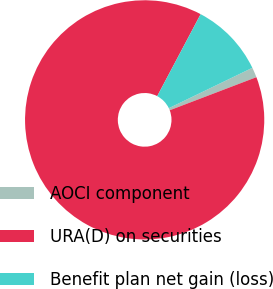Convert chart. <chart><loc_0><loc_0><loc_500><loc_500><pie_chart><fcel>AOCI component<fcel>URA(D) on securities<fcel>Benefit plan net gain (loss)<nl><fcel>1.36%<fcel>88.56%<fcel>10.08%<nl></chart> 